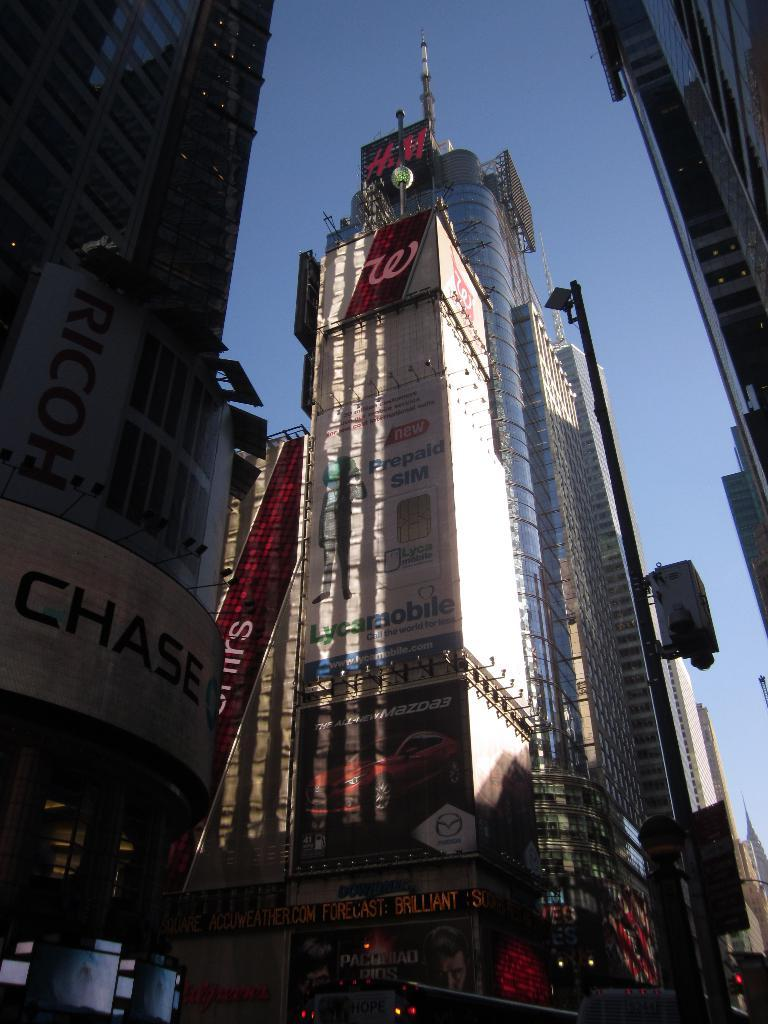What type of structures can be seen in the image? There are buildings with windows in the image. What else is present on the buildings or walls in the image? There is a poster with text in the image. Who is present in the image? There are police officers visible in the image. What can be seen illuminating the scene in the image? There are lights in the image. What is visible in the background of the image? The sky is visible in the image. How does the daughter interact with the police officers in the image? There is no daughter present in the image; only police officers are visible. Can you describe the kiss between the two individuals in the image? There are no individuals kissing in the image; the scene features police officers and buildings. 